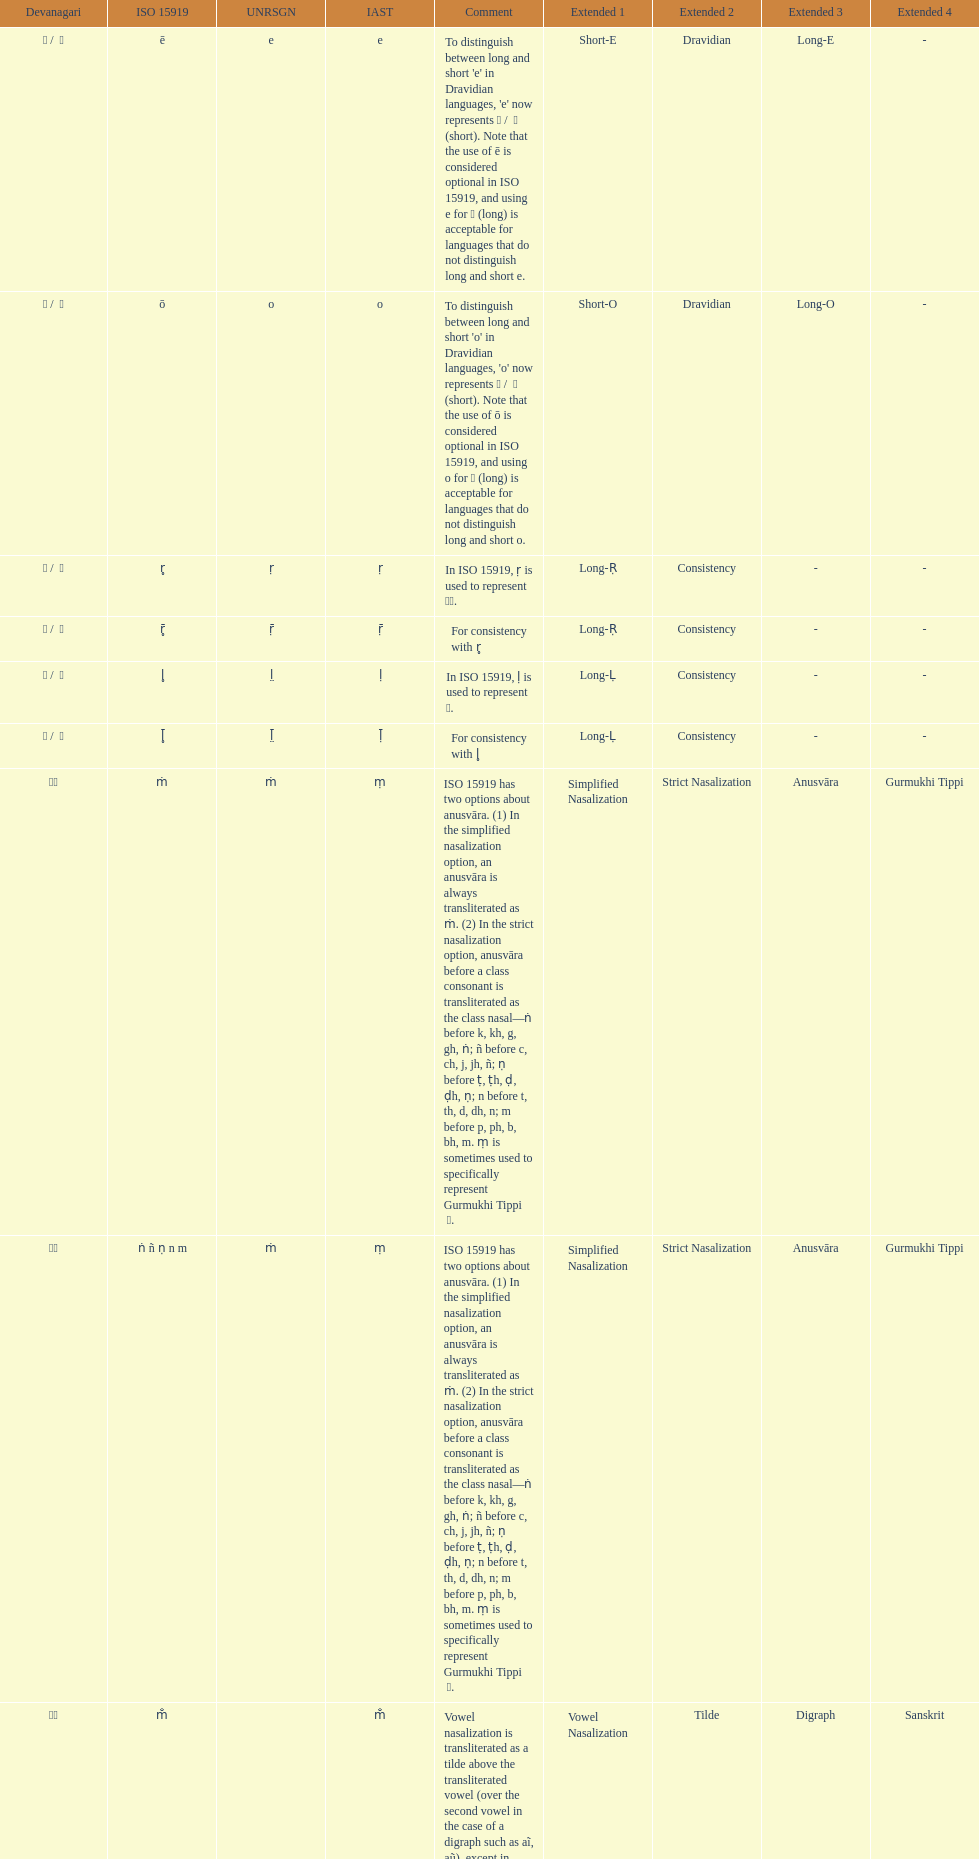Which devanagaria means the same as this iast letter: o? ओ / ो. 